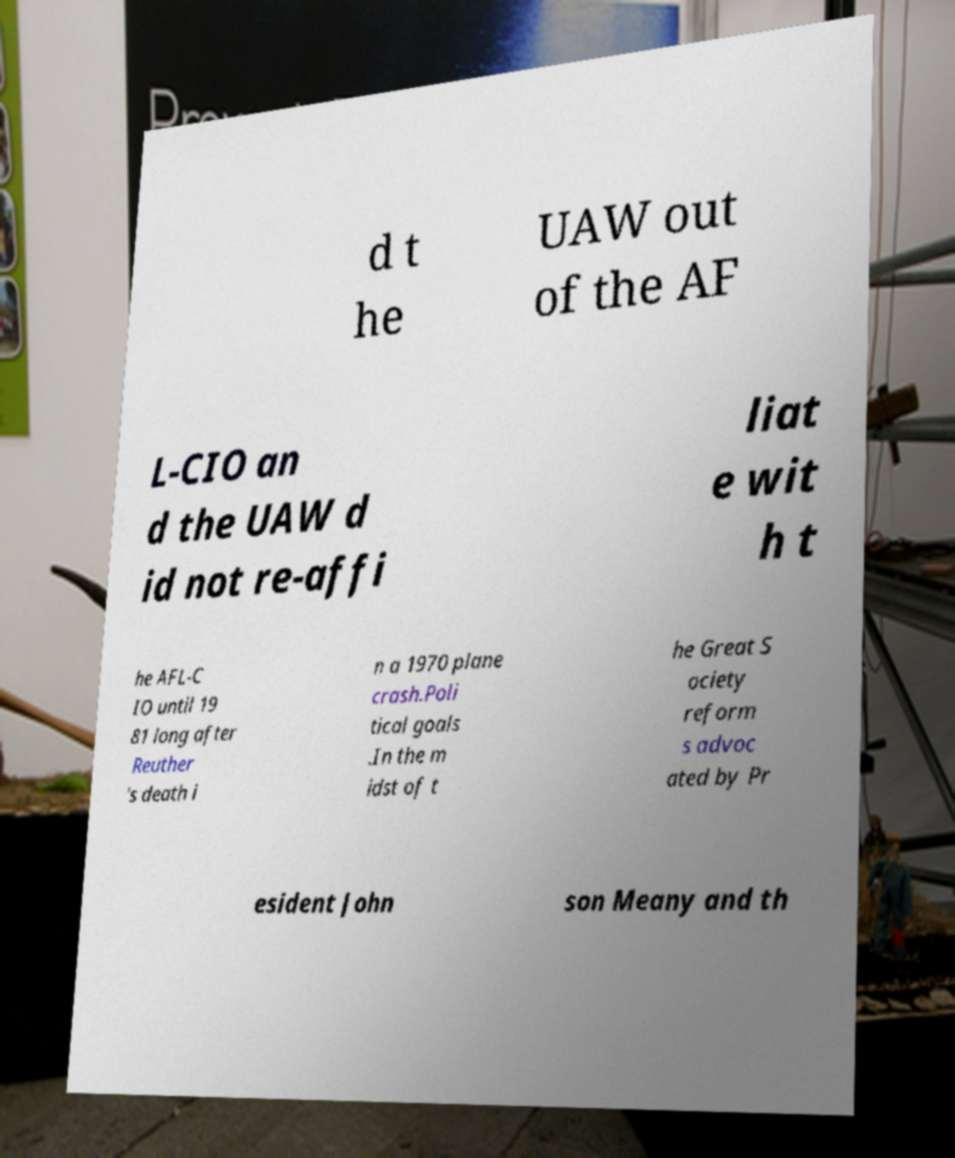Can you accurately transcribe the text from the provided image for me? d t he UAW out of the AF L-CIO an d the UAW d id not re-affi liat e wit h t he AFL-C IO until 19 81 long after Reuther 's death i n a 1970 plane crash.Poli tical goals .In the m idst of t he Great S ociety reform s advoc ated by Pr esident John son Meany and th 